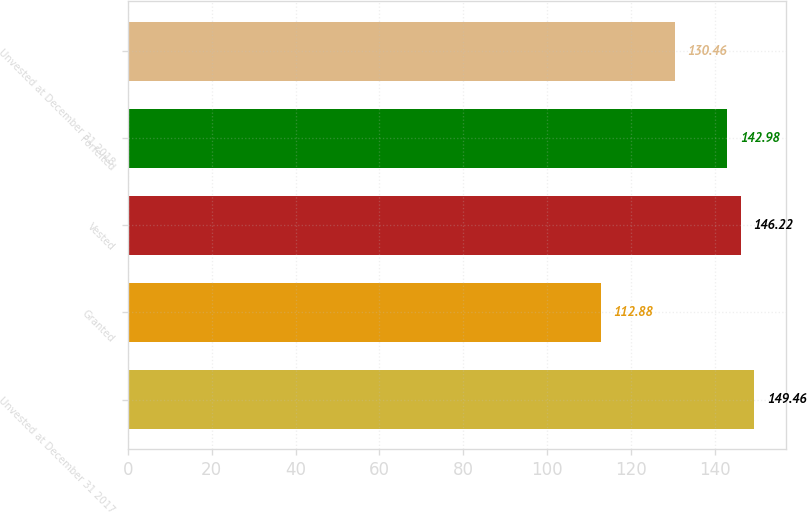Convert chart to OTSL. <chart><loc_0><loc_0><loc_500><loc_500><bar_chart><fcel>Unvested at December 31 2017<fcel>Granted<fcel>Vested<fcel>Forfeited<fcel>Unvested at December 31 2018<nl><fcel>149.46<fcel>112.88<fcel>146.22<fcel>142.98<fcel>130.46<nl></chart> 